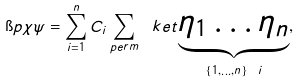<formula> <loc_0><loc_0><loc_500><loc_500>\i p { \chi } { \psi } = \sum _ { i = 1 } ^ { n } C _ { i } \sum _ { p e r m } \ k e t { \underbrace { \eta _ { 1 } \dots \eta _ { n } } _ { \{ 1 , \dots , n \} \ i } } ,</formula> 